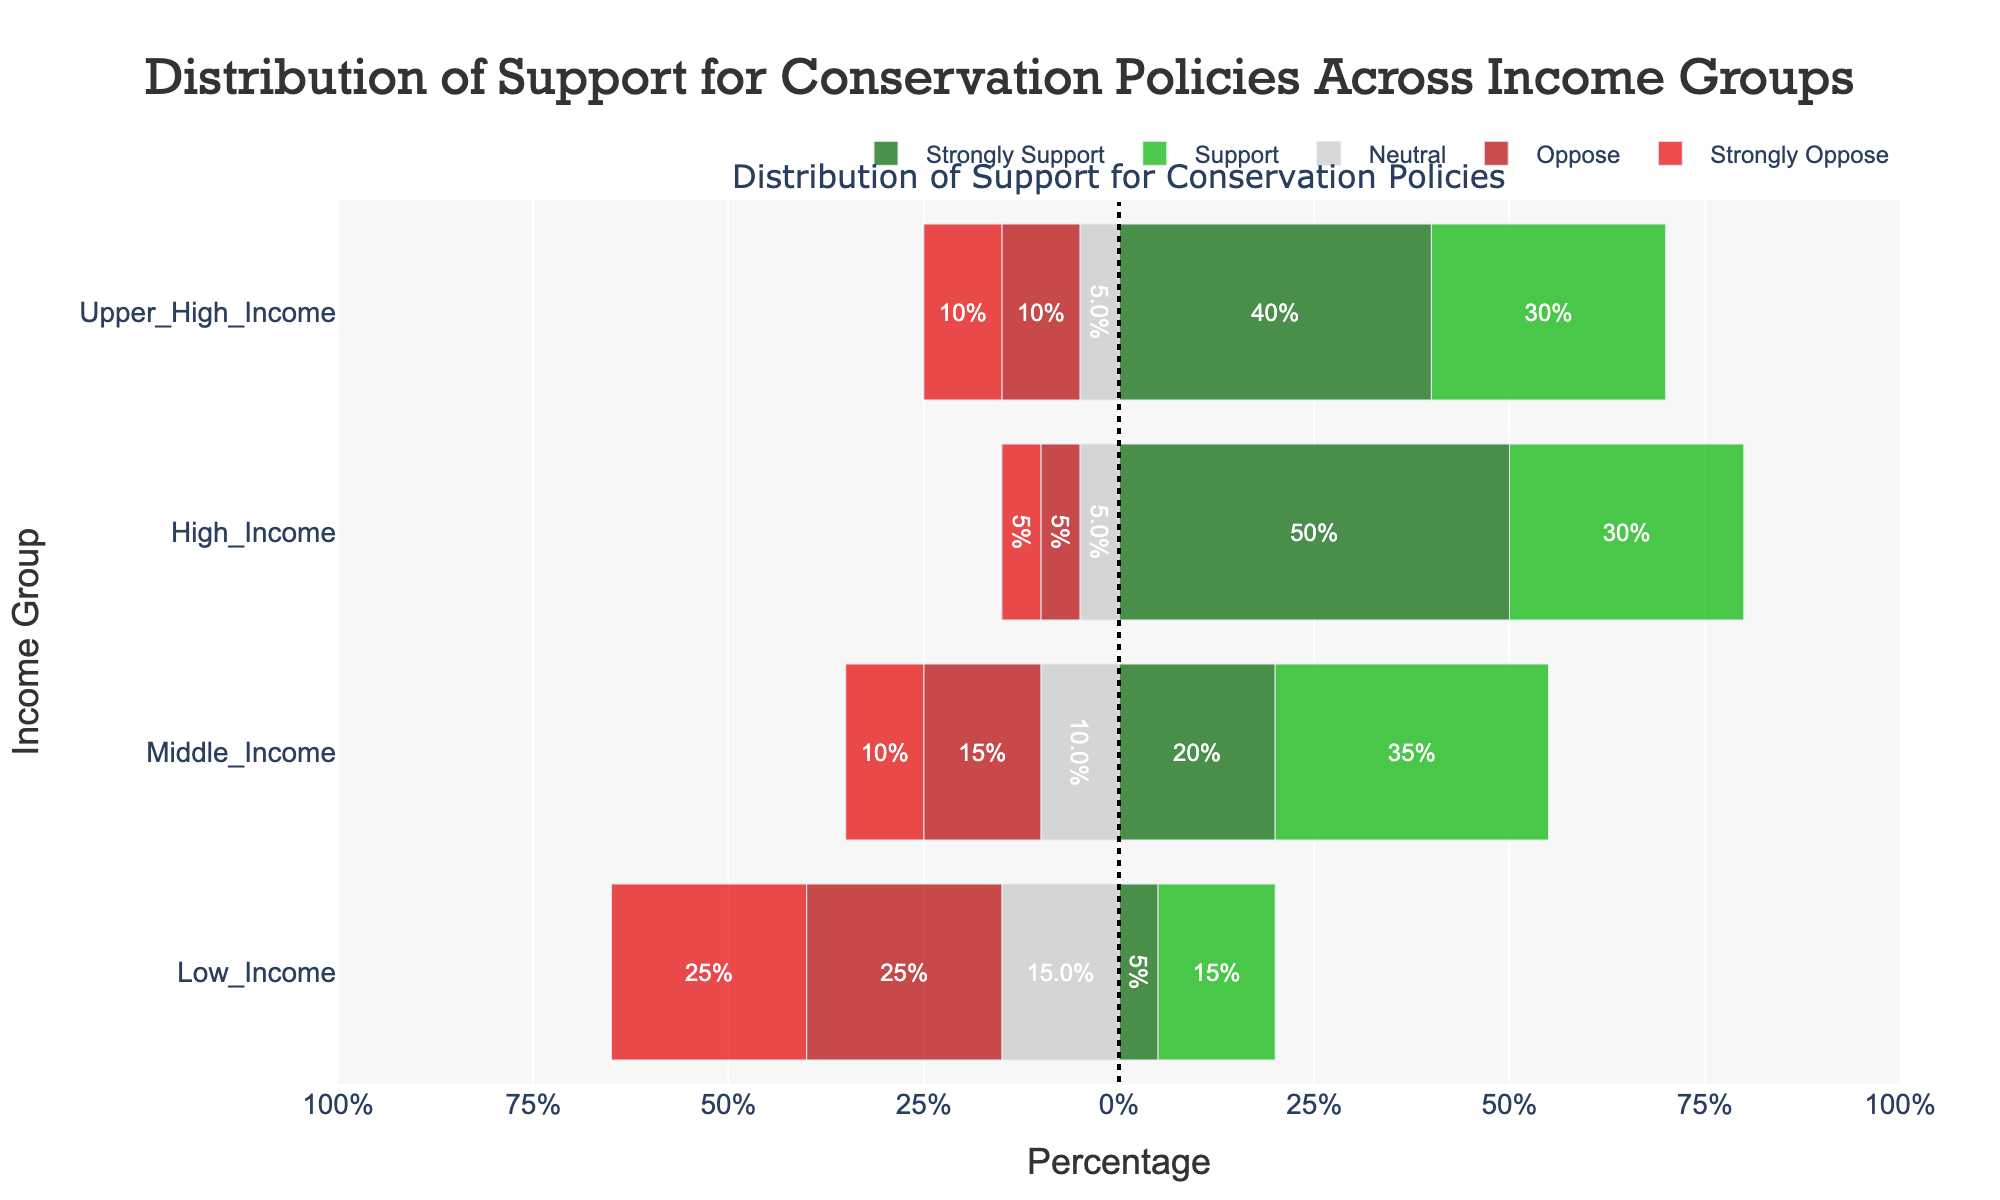How many people in the High Income group support or strongly support conservation policies? Sum the Strongly Support and Support categories for High Income: 50 + 30 = 80%
Answer: 80% Which income group shows the highest percentage of Strongly Oppose? Observe the bars for Strongly Oppose across all income groups. Low Income has the highest (25%).
Answer: Low Income Compare the Neutral stance between Low Income and High Income groups. Which has a larger percentage? Observe the Neutral category for both groups: Low Income = 30%, High Income = 10%.
Answer: Low Income What is the net support (Strongly Support + Support - Oppose - Strongly Oppose) for Middle Income? Calculate the net support: (20 + 35) - (15 + 10) = 70 - 25 = 45%
Answer: 45% What is the combined percentage of Oppose and Strongly Oppose for Upper High Income? Sum the Oppose and Strongly Oppose categories for Upper High Income: 10 + 10 = 20%
Answer: 20% How much higher is the Strongly Support percentage in High Income compared to Lower Income? Find the difference between Strongly Support percentages: 50% (High Income) - 5% (Low Income) = 45%
Answer: 45% Of the income groups listed, which one has the highest combined opposition (Oppose and Strongly Oppose) percentage? Sum the Oppose and Strongly Oppose categories for each group and compare: Low Income = 25 + 25 = 50%, Middle Income = 15 + 10 = 25%, High Income = 5 + 5 = 10%, Upper High Income = 10 + 10 = 20%. Low Income has the highest opposition percentage.
Answer: Low Income 